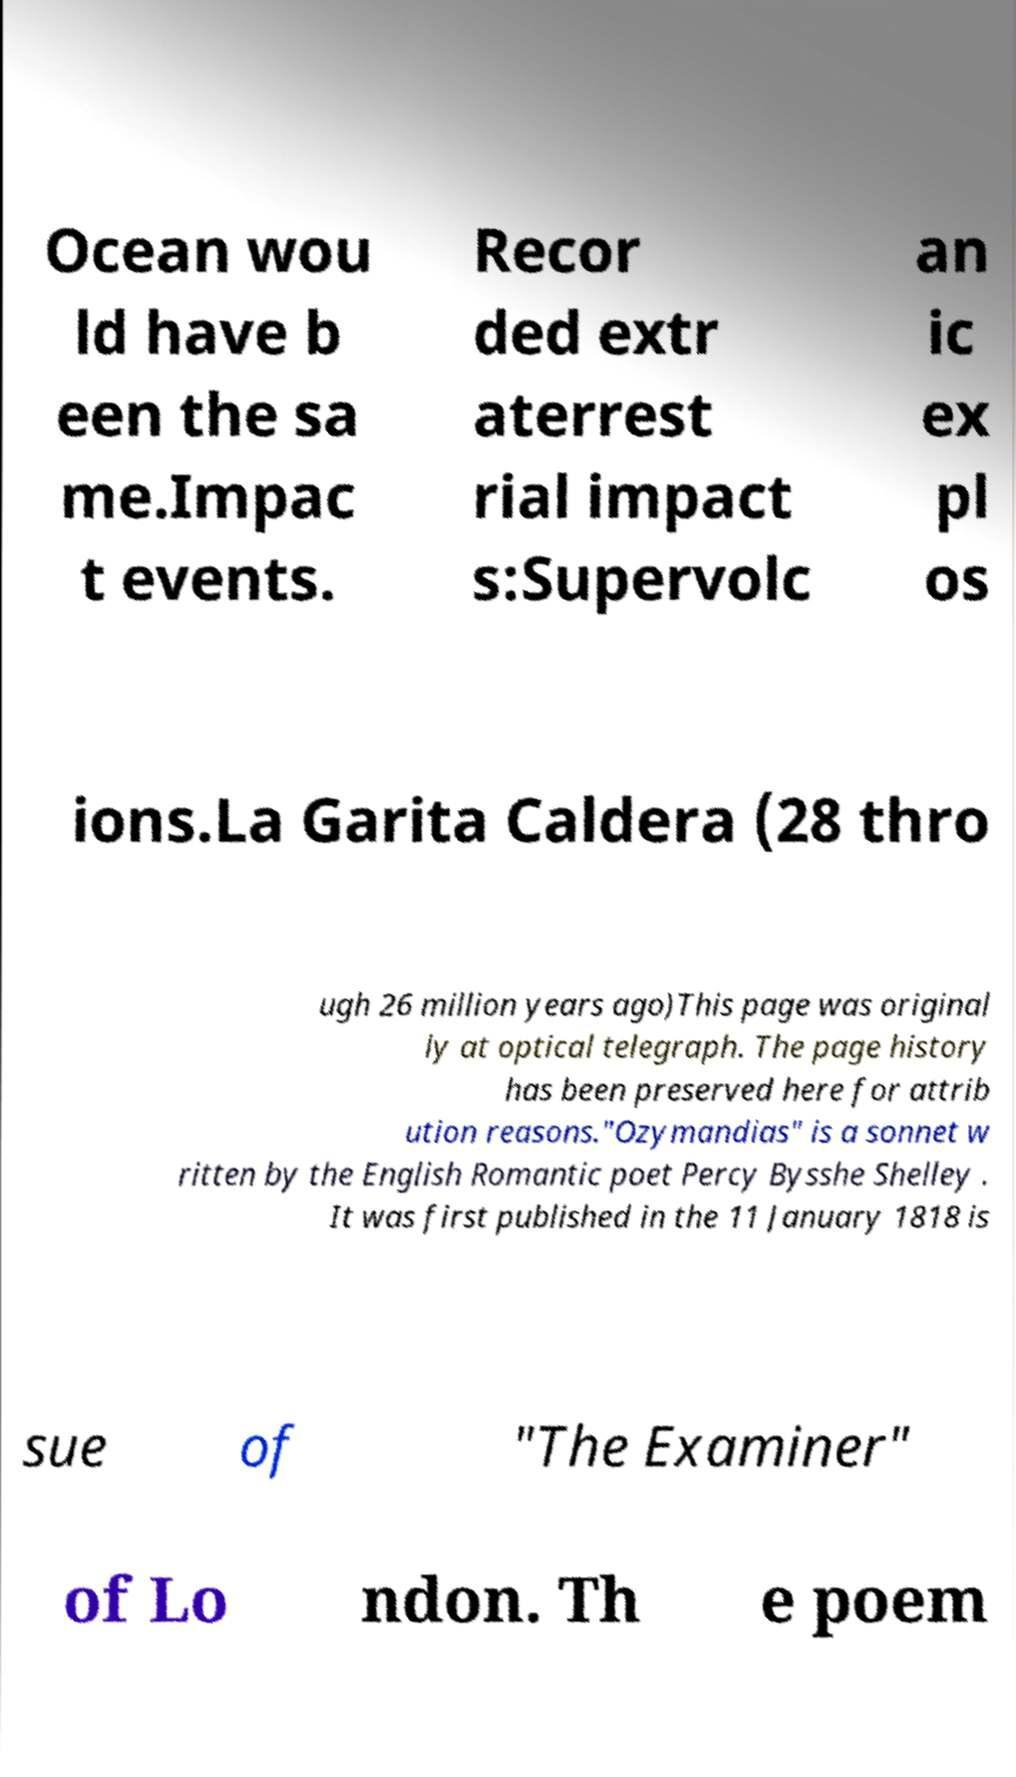I need the written content from this picture converted into text. Can you do that? Ocean wou ld have b een the sa me.Impac t events. Recor ded extr aterrest rial impact s:Supervolc an ic ex pl os ions.La Garita Caldera (28 thro ugh 26 million years ago)This page was original ly at optical telegraph. The page history has been preserved here for attrib ution reasons."Ozymandias" is a sonnet w ritten by the English Romantic poet Percy Bysshe Shelley . It was first published in the 11 January 1818 is sue of "The Examiner" of Lo ndon. Th e poem 